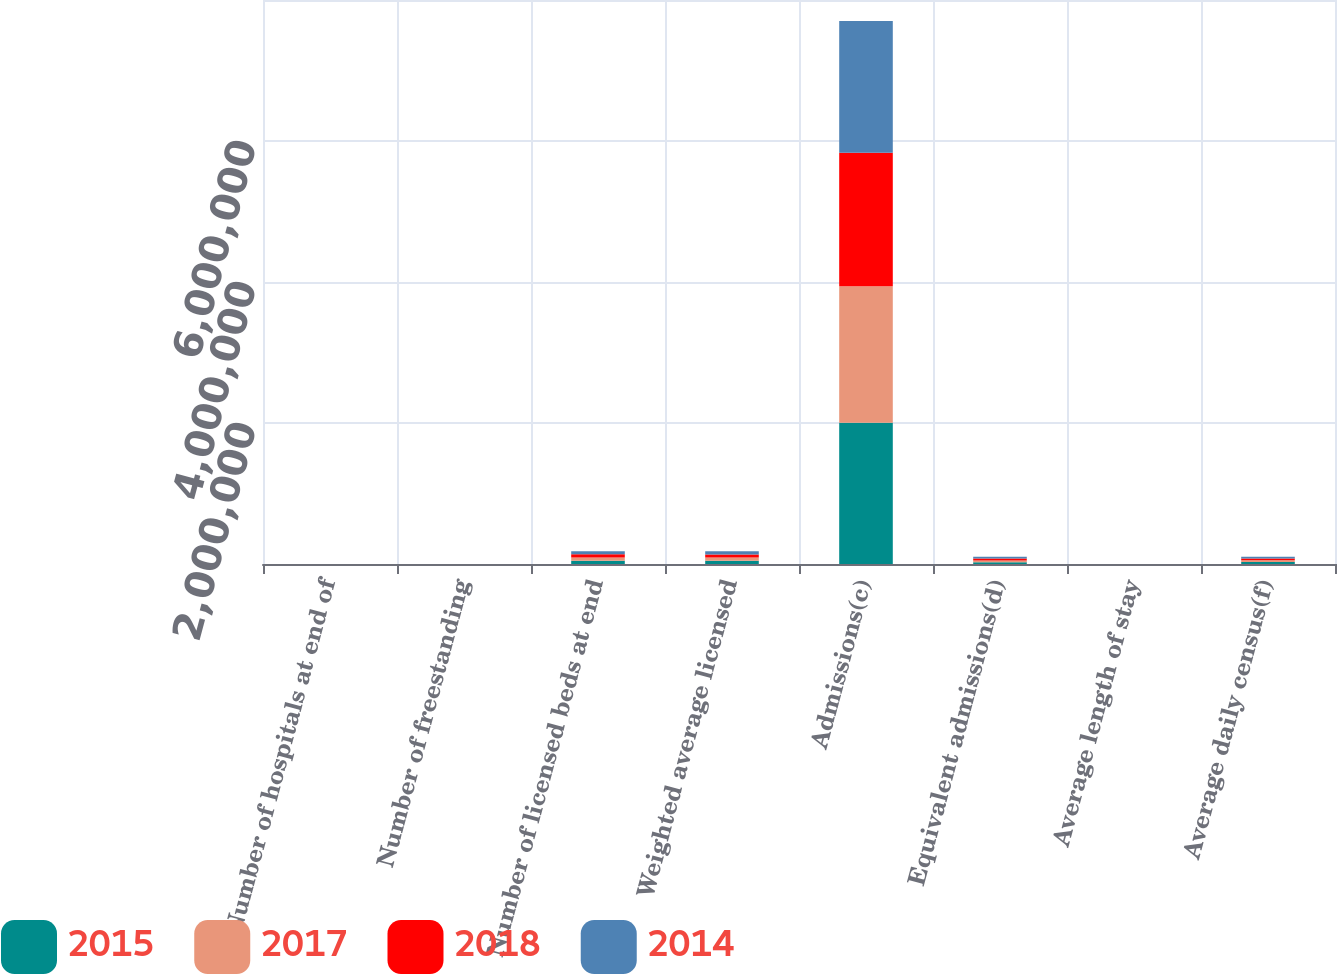Convert chart to OTSL. <chart><loc_0><loc_0><loc_500><loc_500><stacked_bar_chart><ecel><fcel>Number of hospitals at end of<fcel>Number of freestanding<fcel>Number of licensed beds at end<fcel>Weighted average licensed<fcel>Admissions(c)<fcel>Equivalent admissions(d)<fcel>Average length of stay<fcel>Average daily census(f)<nl><fcel>2015<fcel>179<fcel>123<fcel>47199<fcel>46857<fcel>2.00375e+06<fcel>25670<fcel>4.9<fcel>26663<nl><fcel>2017<fcel>179<fcel>120<fcel>46738<fcel>45380<fcel>1.93661e+06<fcel>25670<fcel>4.9<fcel>26000<nl><fcel>2018<fcel>170<fcel>118<fcel>44290<fcel>44077<fcel>1.89183e+06<fcel>25670<fcel>4.9<fcel>25340<nl><fcel>2014<fcel>168<fcel>116<fcel>43771<fcel>43620<fcel>1.86879e+06<fcel>25670<fcel>4.9<fcel>25084<nl></chart> 